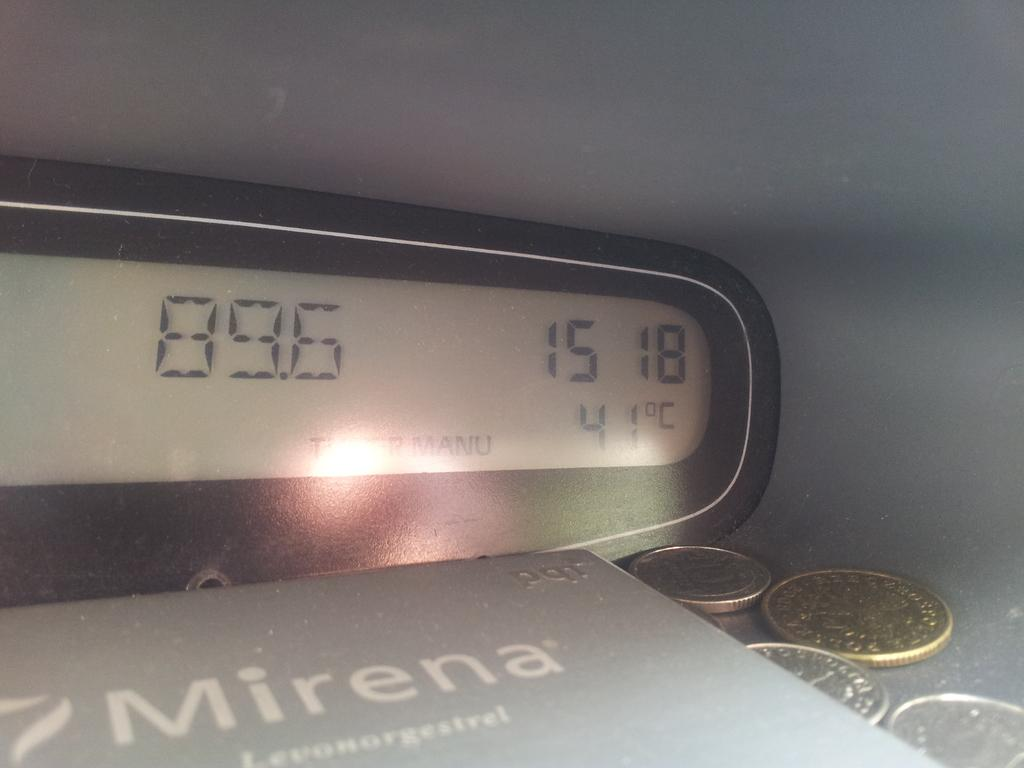<image>
Summarize the visual content of the image. Coins are lying on a table with an alarm clock set to station 89.6 and shows the temp at 41 degrees 